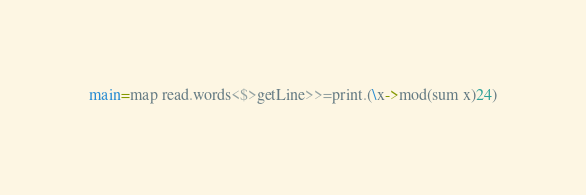<code> <loc_0><loc_0><loc_500><loc_500><_Haskell_>main=map read.words<$>getLine>>=print.(\x->mod(sum x)24)</code> 